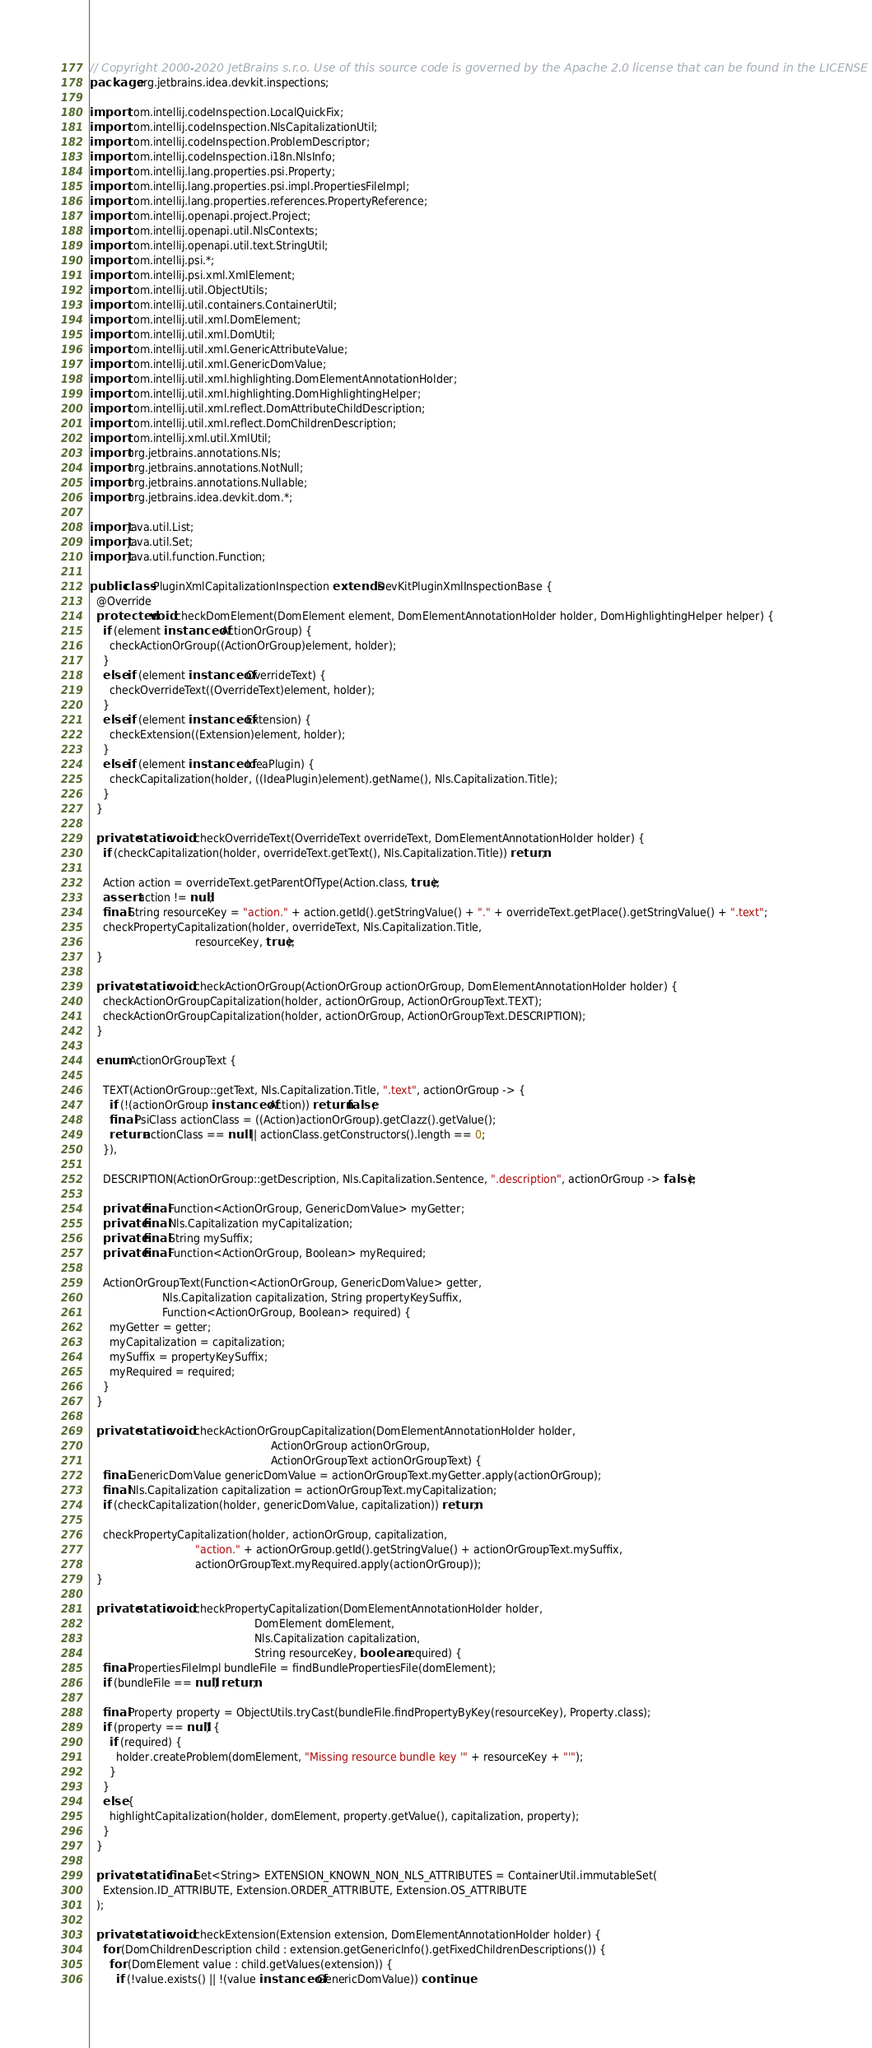<code> <loc_0><loc_0><loc_500><loc_500><_Java_>// Copyright 2000-2020 JetBrains s.r.o. Use of this source code is governed by the Apache 2.0 license that can be found in the LICENSE file.
package org.jetbrains.idea.devkit.inspections;

import com.intellij.codeInspection.LocalQuickFix;
import com.intellij.codeInspection.NlsCapitalizationUtil;
import com.intellij.codeInspection.ProblemDescriptor;
import com.intellij.codeInspection.i18n.NlsInfo;
import com.intellij.lang.properties.psi.Property;
import com.intellij.lang.properties.psi.impl.PropertiesFileImpl;
import com.intellij.lang.properties.references.PropertyReference;
import com.intellij.openapi.project.Project;
import com.intellij.openapi.util.NlsContexts;
import com.intellij.openapi.util.text.StringUtil;
import com.intellij.psi.*;
import com.intellij.psi.xml.XmlElement;
import com.intellij.util.ObjectUtils;
import com.intellij.util.containers.ContainerUtil;
import com.intellij.util.xml.DomElement;
import com.intellij.util.xml.DomUtil;
import com.intellij.util.xml.GenericAttributeValue;
import com.intellij.util.xml.GenericDomValue;
import com.intellij.util.xml.highlighting.DomElementAnnotationHolder;
import com.intellij.util.xml.highlighting.DomHighlightingHelper;
import com.intellij.util.xml.reflect.DomAttributeChildDescription;
import com.intellij.util.xml.reflect.DomChildrenDescription;
import com.intellij.xml.util.XmlUtil;
import org.jetbrains.annotations.Nls;
import org.jetbrains.annotations.NotNull;
import org.jetbrains.annotations.Nullable;
import org.jetbrains.idea.devkit.dom.*;

import java.util.List;
import java.util.Set;
import java.util.function.Function;

public class PluginXmlCapitalizationInspection extends DevKitPluginXmlInspectionBase {
  @Override
  protected void checkDomElement(DomElement element, DomElementAnnotationHolder holder, DomHighlightingHelper helper) {
    if (element instanceof ActionOrGroup) {
      checkActionOrGroup((ActionOrGroup)element, holder);
    }
    else if (element instanceof OverrideText) {
      checkOverrideText((OverrideText)element, holder);
    }
    else if (element instanceof Extension) {
      checkExtension((Extension)element, holder);
    }
    else if (element instanceof IdeaPlugin) {
      checkCapitalization(holder, ((IdeaPlugin)element).getName(), Nls.Capitalization.Title);
    }
  }

  private static void checkOverrideText(OverrideText overrideText, DomElementAnnotationHolder holder) {
    if (checkCapitalization(holder, overrideText.getText(), Nls.Capitalization.Title)) return;

    Action action = overrideText.getParentOfType(Action.class, true);
    assert action != null;
    final String resourceKey = "action." + action.getId().getStringValue() + "." + overrideText.getPlace().getStringValue() + ".text";
    checkPropertyCapitalization(holder, overrideText, Nls.Capitalization.Title,
                                resourceKey, true);
  }

  private static void checkActionOrGroup(ActionOrGroup actionOrGroup, DomElementAnnotationHolder holder) {
    checkActionOrGroupCapitalization(holder, actionOrGroup, ActionOrGroupText.TEXT);
    checkActionOrGroupCapitalization(holder, actionOrGroup, ActionOrGroupText.DESCRIPTION);
  }

  enum ActionOrGroupText {

    TEXT(ActionOrGroup::getText, Nls.Capitalization.Title, ".text", actionOrGroup -> {
      if (!(actionOrGroup instanceof Action)) return false;
      final PsiClass actionClass = ((Action)actionOrGroup).getClazz().getValue();
      return actionClass == null || actionClass.getConstructors().length == 0;
    }),

    DESCRIPTION(ActionOrGroup::getDescription, Nls.Capitalization.Sentence, ".description", actionOrGroup -> false);

    private final Function<ActionOrGroup, GenericDomValue> myGetter;
    private final Nls.Capitalization myCapitalization;
    private final String mySuffix;
    private final Function<ActionOrGroup, Boolean> myRequired;

    ActionOrGroupText(Function<ActionOrGroup, GenericDomValue> getter,
                      Nls.Capitalization capitalization, String propertyKeySuffix,
                      Function<ActionOrGroup, Boolean> required) {
      myGetter = getter;
      myCapitalization = capitalization;
      mySuffix = propertyKeySuffix;
      myRequired = required;
    }
  }

  private static void checkActionOrGroupCapitalization(DomElementAnnotationHolder holder,
                                                       ActionOrGroup actionOrGroup,
                                                       ActionOrGroupText actionOrGroupText) {
    final GenericDomValue genericDomValue = actionOrGroupText.myGetter.apply(actionOrGroup);
    final Nls.Capitalization capitalization = actionOrGroupText.myCapitalization;
    if (checkCapitalization(holder, genericDomValue, capitalization)) return;

    checkPropertyCapitalization(holder, actionOrGroup, capitalization,
                                "action." + actionOrGroup.getId().getStringValue() + actionOrGroupText.mySuffix,
                                actionOrGroupText.myRequired.apply(actionOrGroup));
  }

  private static void checkPropertyCapitalization(DomElementAnnotationHolder holder,
                                                  DomElement domElement,
                                                  Nls.Capitalization capitalization,
                                                  String resourceKey, boolean required) {
    final PropertiesFileImpl bundleFile = findBundlePropertiesFile(domElement);
    if (bundleFile == null) return;

    final Property property = ObjectUtils.tryCast(bundleFile.findPropertyByKey(resourceKey), Property.class);
    if (property == null) {
      if (required) {
        holder.createProblem(domElement, "Missing resource bundle key '" + resourceKey + "'");
      }
    }
    else {
      highlightCapitalization(holder, domElement, property.getValue(), capitalization, property);
    }
  }

  private static final Set<String> EXTENSION_KNOWN_NON_NLS_ATTRIBUTES = ContainerUtil.immutableSet(
    Extension.ID_ATTRIBUTE, Extension.ORDER_ATTRIBUTE, Extension.OS_ATTRIBUTE
  );

  private static void checkExtension(Extension extension, DomElementAnnotationHolder holder) {
    for (DomChildrenDescription child : extension.getGenericInfo().getFixedChildrenDescriptions()) {
      for (DomElement value : child.getValues(extension)) {
        if (!value.exists() || !(value instanceof GenericDomValue)) continue;
</code> 